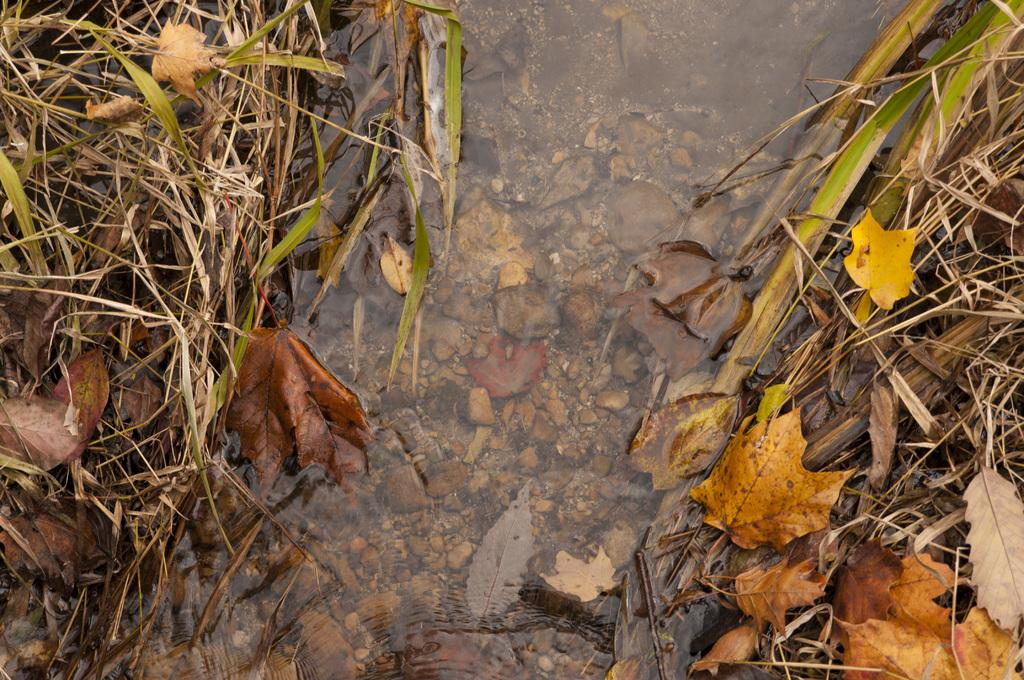What type of vegetation can be seen in the image? There are dried leaves and dried grass in the image. What is the condition of the vegetation? The vegetation is dried. What else is present in the image besides vegetation? Stones are present in the water in the image. What type of knee injury can be seen in the image? There is no knee injury present in the image; it features dried leaves, dried grass, and stones in the water. What type of war is depicted in the image? There is no depiction of war in the image; it features natural elements like vegetation and stones in the water. 